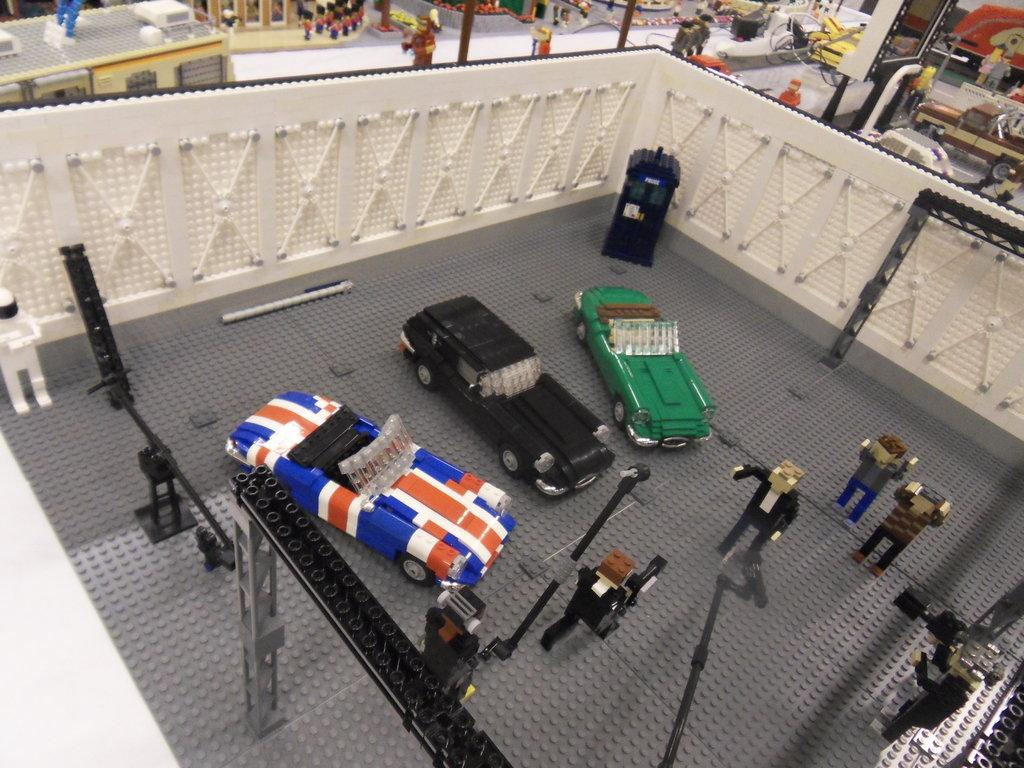What type of vehicles can be seen in the image? There are cars in the image. What are the people on the ground doing? There are people on the ground in the image, but their actions are not specified. What is at the top of the image? There is a wall at the top of the image. What can be seen in the background of the image? There are vehicles, people, and many other objects in the background of the image. What type of health benefits can be gained from the beam in the image? There is no beam present in the image, so it is not possible to discuss any health benefits related to it. 